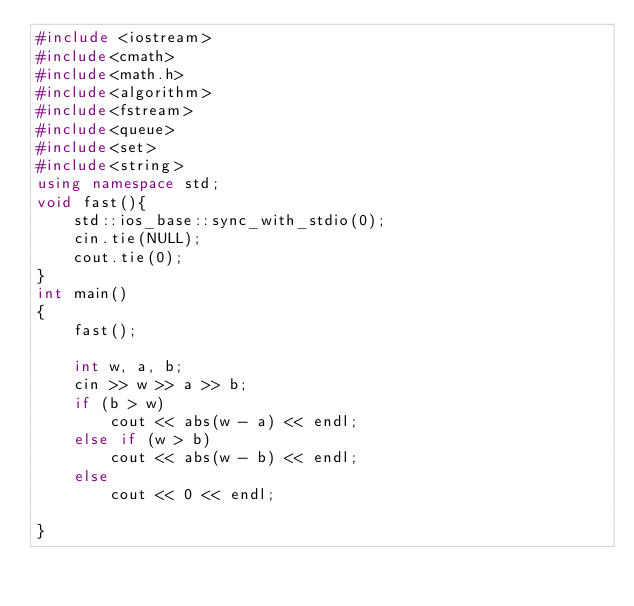<code> <loc_0><loc_0><loc_500><loc_500><_C++_>#include <iostream>
#include<cmath>
#include<math.h>
#include<algorithm>
#include<fstream>
#include<queue>
#include<set>
#include<string>
using namespace std;
void fast(){
	std::ios_base::sync_with_stdio(0);
	cin.tie(NULL);
	cout.tie(0);
}
int main()
{
	fast();

	int w, a, b;
	cin >> w >> a >> b;
	if (b > w)
		cout << abs(w - a) << endl;
	else if (w > b)
		cout << abs(w - b) << endl;
	else
		cout << 0 << endl;
	
}</code> 